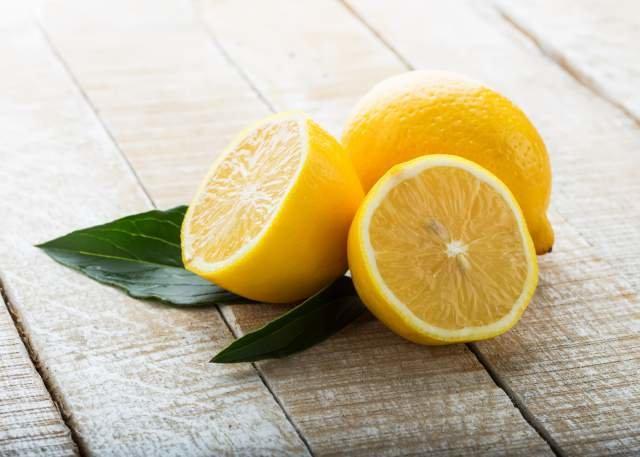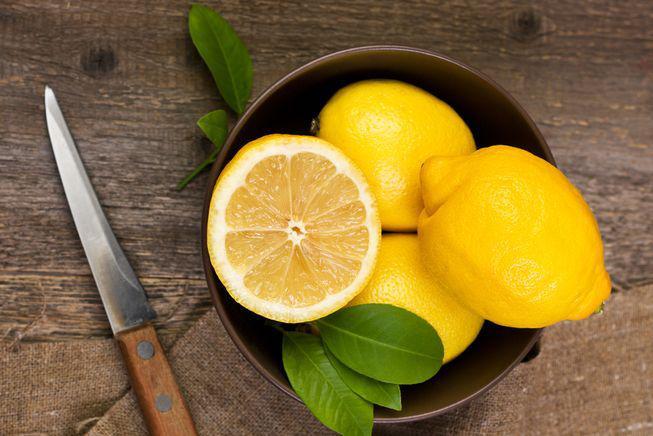The first image is the image on the left, the second image is the image on the right. Assess this claim about the two images: "Each image contains green leaves, lemon half, and whole lemon.". Correct or not? Answer yes or no. Yes. The first image is the image on the left, the second image is the image on the right. Analyze the images presented: Is the assertion "There are exactly three uncut lemons." valid? Answer yes or no. No. 